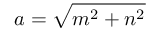<formula> <loc_0><loc_0><loc_500><loc_500>a = { \sqrt { m ^ { 2 } + n ^ { 2 } } }</formula> 